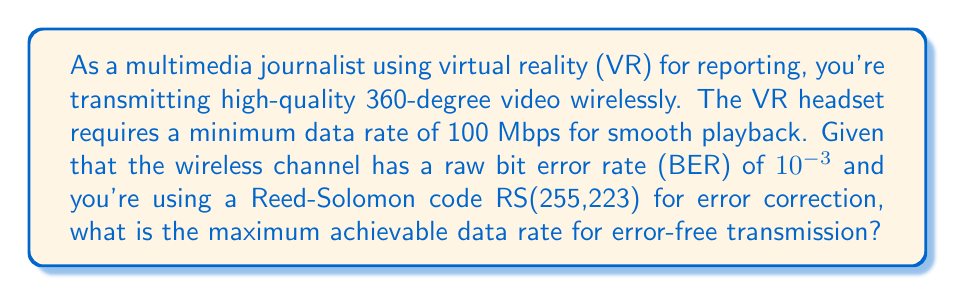What is the answer to this math problem? To solve this problem, we need to follow these steps:

1) First, let's understand the Reed-Solomon code RS(255,223):
   - Each codeword contains 255 symbols
   - 223 of these symbols are data
   - 32 symbols are for error correction (255 - 223 = 32)

2) The code rate $R$ is the ratio of data symbols to total symbols:
   $$R = \frac{223}{255} \approx 0.8745$$

3) In a Reed-Solomon code, each symbol error can corrupt an entire byte. The probability of a symbol error $P_s$ is related to the bit error rate (BER) as:
   $$P_s = 1 - (1 - BER)^8 = 1 - (1 - 10^{-3})^8 \approx 0.007968$$

4) The Reed-Solomon code RS(255,223) can correct up to 16 symbol errors (half of the 32 parity symbols). The probability of decoder failure $P_f$ is the probability of more than 16 errors occurring:
   $$P_f = \sum_{i=17}^{255} \binom{255}{i} P_s^i (1-P_s)^{255-i}$$

   This can be approximated using the normal distribution:
   $$P_f \approx Q\left(\frac{16.5 - 255P_s}{\sqrt{255P_s(1-P_s)}}\right) \approx 1.65 \times 10^{-8}$$

5) The channel efficiency $\eta$ is:
   $$\eta = R(1-P_f) \approx 0.8745 \times (1 - 1.65 \times 10^{-8}) \approx 0.8745$$

6) The maximum achievable data rate is:
   $$\text{Max Data Rate} = \frac{100 \text{ Mbps}}{\eta} \approx \frac{100}{0.8745} \approx 114.35 \text{ Mbps}$$

Therefore, to achieve an error-free data rate of 100 Mbps, you need to transmit at approximately 114.35 Mbps.
Answer: 114.35 Mbps 